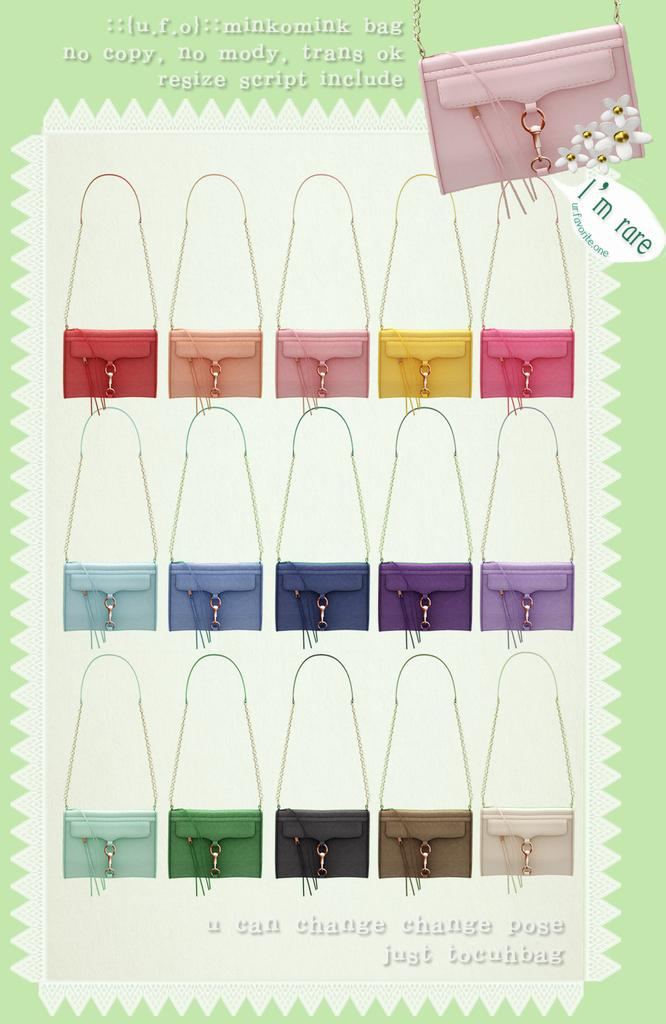What type of content is featured in the image? The image is an advertisement. What objects can be seen in the advertisement? There are bags in the image. Is there any text present in the image? Yes, there is text in the image. Can you see any bees buzzing around the bags in the image? There are no bees present in the image. Is there a lake visible in the background of the image? There is no lake visible in the image. 